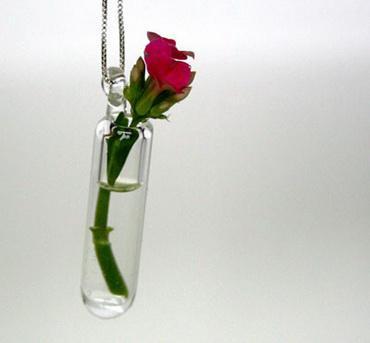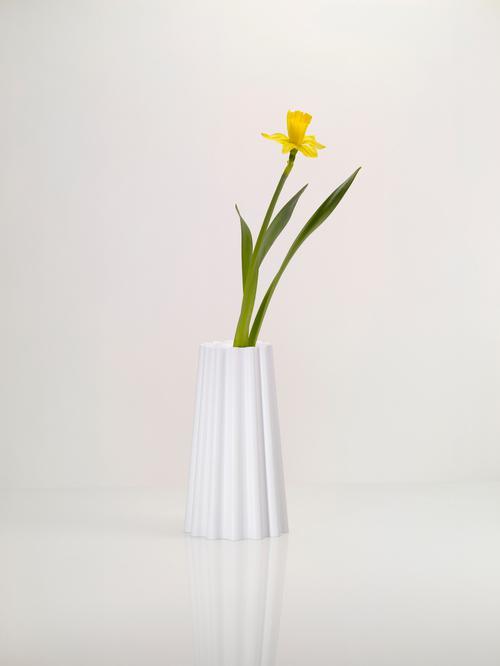The first image is the image on the left, the second image is the image on the right. Considering the images on both sides, is "The flower in the white vase on the right is yellow." valid? Answer yes or no. Yes. 